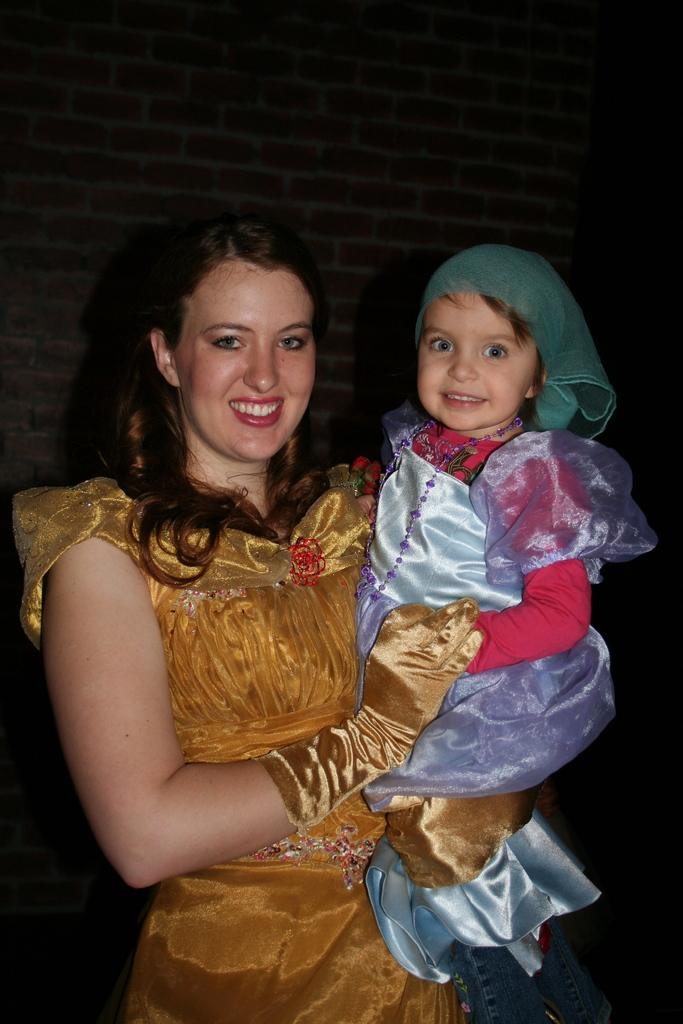What is the woman in the image carrying? The woman is carrying a child. What is the emotional state of the woman and the child in the image? Both the woman and the child are smiling. What accessory is the woman wearing in the image? The woman is wearing gloves. What type of lumber is being used to build the house in the image? There is no house present in the image; it features a woman carrying a child. What is the power source for the guitar in the image? There is no guitar present in the image; it features a woman carrying a child. 